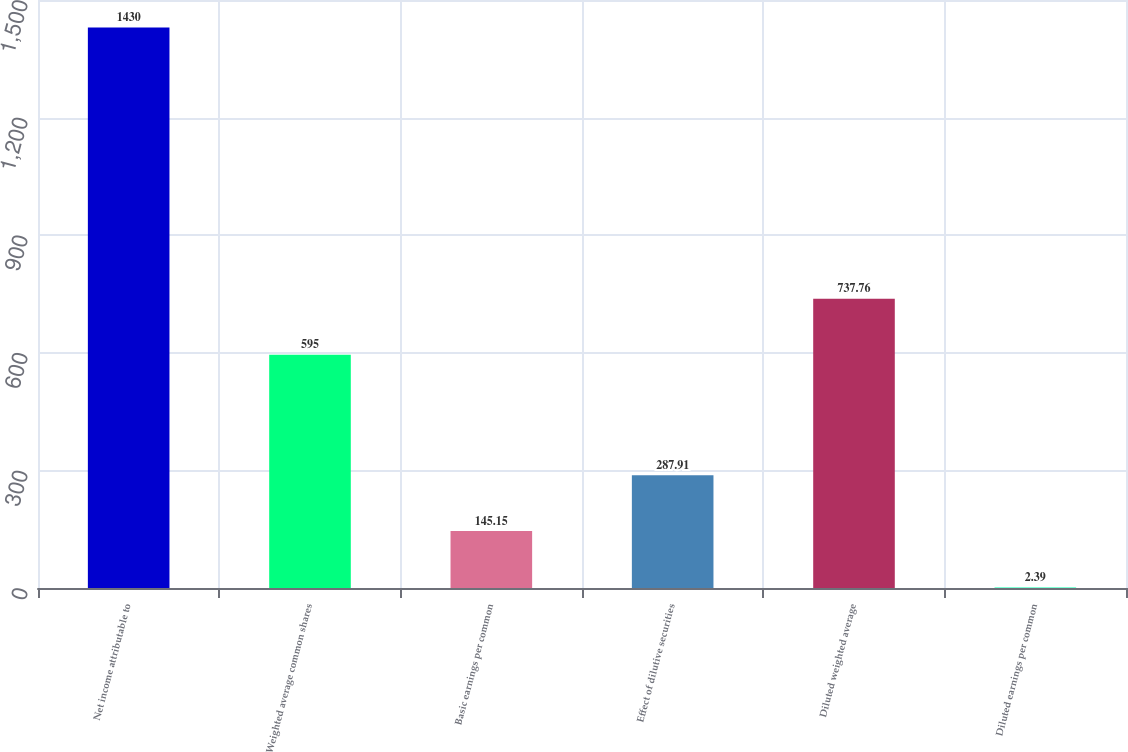<chart> <loc_0><loc_0><loc_500><loc_500><bar_chart><fcel>Net income attributable to<fcel>Weighted average common shares<fcel>Basic earnings per common<fcel>Effect of dilutive securities<fcel>Diluted weighted average<fcel>Diluted earnings per common<nl><fcel>1430<fcel>595<fcel>145.15<fcel>287.91<fcel>737.76<fcel>2.39<nl></chart> 